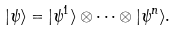<formula> <loc_0><loc_0><loc_500><loc_500>| \psi \rangle = | \psi ^ { 1 } \rangle \otimes \dots \otimes | \psi ^ { n } \rangle .</formula> 